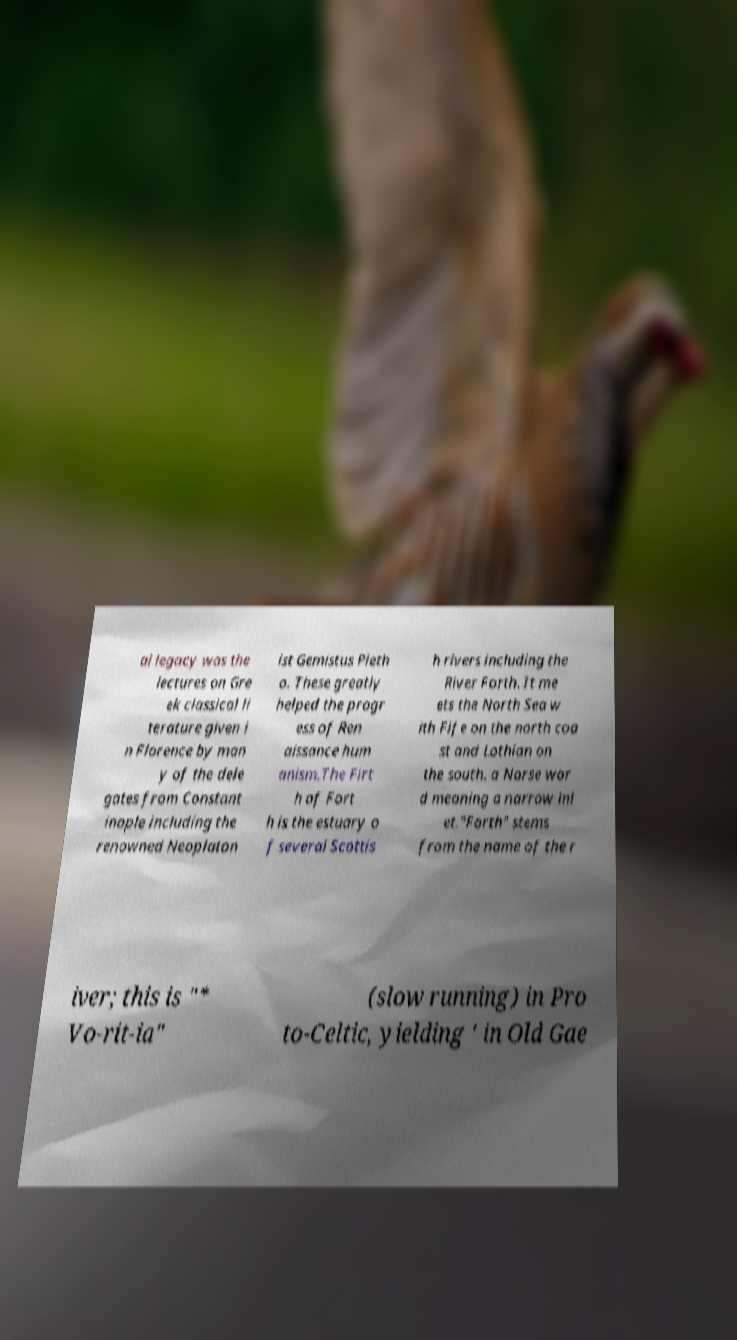Could you assist in decoding the text presented in this image and type it out clearly? al legacy was the lectures on Gre ek classical li terature given i n Florence by man y of the dele gates from Constant inople including the renowned Neoplaton ist Gemistus Pleth o. These greatly helped the progr ess of Ren aissance hum anism.The Firt h of Fort h is the estuary o f several Scottis h rivers including the River Forth. It me ets the North Sea w ith Fife on the north coa st and Lothian on the south. a Norse wor d meaning a narrow inl et."Forth" stems from the name of the r iver; this is "* Vo-rit-ia" (slow running) in Pro to-Celtic, yielding ' in Old Gae 